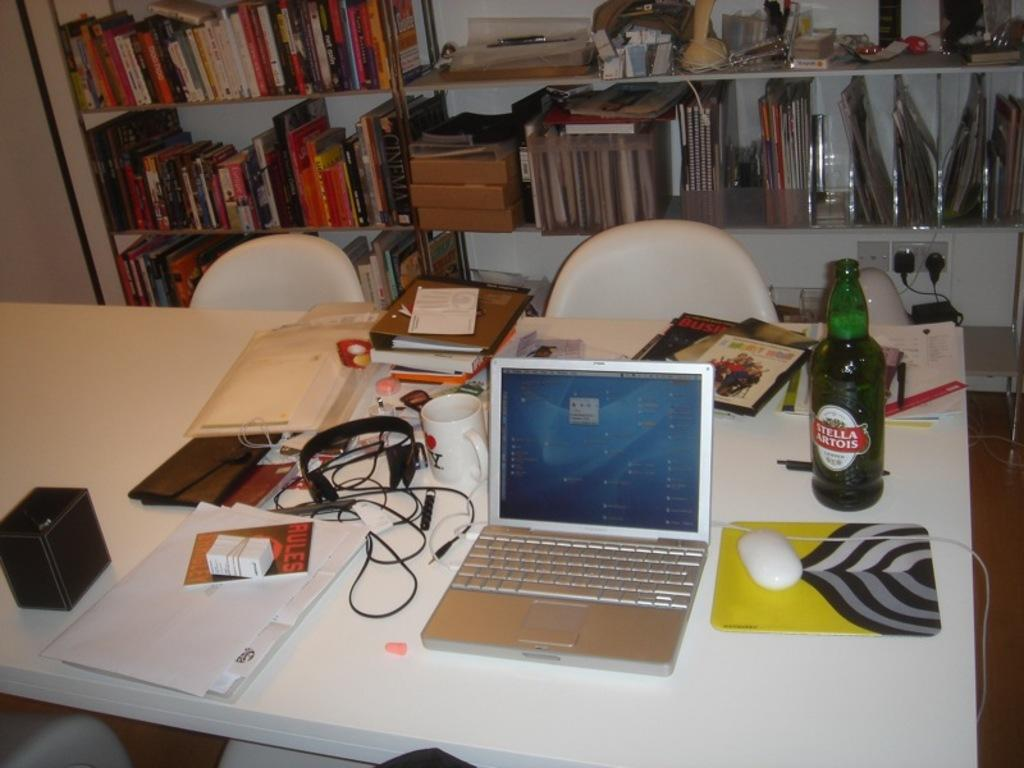What is the main piece of furniture in the image? There is a table in the image. What is on top of the table? There is a mouse, a laptop, a wireless device, a headset, a cup, a bottle, books, papers, and a box on the table. What type of device is on the table for communication or entertainment? There is a wireless device and a headset on the table. What can be seen in the background of the image? There are chairs and books in racks in the background of the image. What type of feather can be seen on the table in the image? There is no feather present on the table in the image. How does the transport system function in the image? There is no transport system depicted in the image; it is a table with various objects on it. 